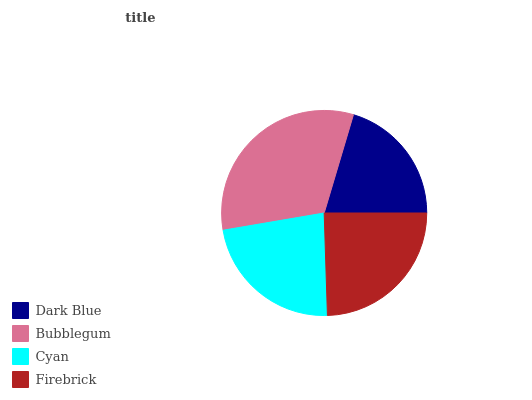Is Dark Blue the minimum?
Answer yes or no. Yes. Is Bubblegum the maximum?
Answer yes or no. Yes. Is Cyan the minimum?
Answer yes or no. No. Is Cyan the maximum?
Answer yes or no. No. Is Bubblegum greater than Cyan?
Answer yes or no. Yes. Is Cyan less than Bubblegum?
Answer yes or no. Yes. Is Cyan greater than Bubblegum?
Answer yes or no. No. Is Bubblegum less than Cyan?
Answer yes or no. No. Is Firebrick the high median?
Answer yes or no. Yes. Is Cyan the low median?
Answer yes or no. Yes. Is Bubblegum the high median?
Answer yes or no. No. Is Bubblegum the low median?
Answer yes or no. No. 